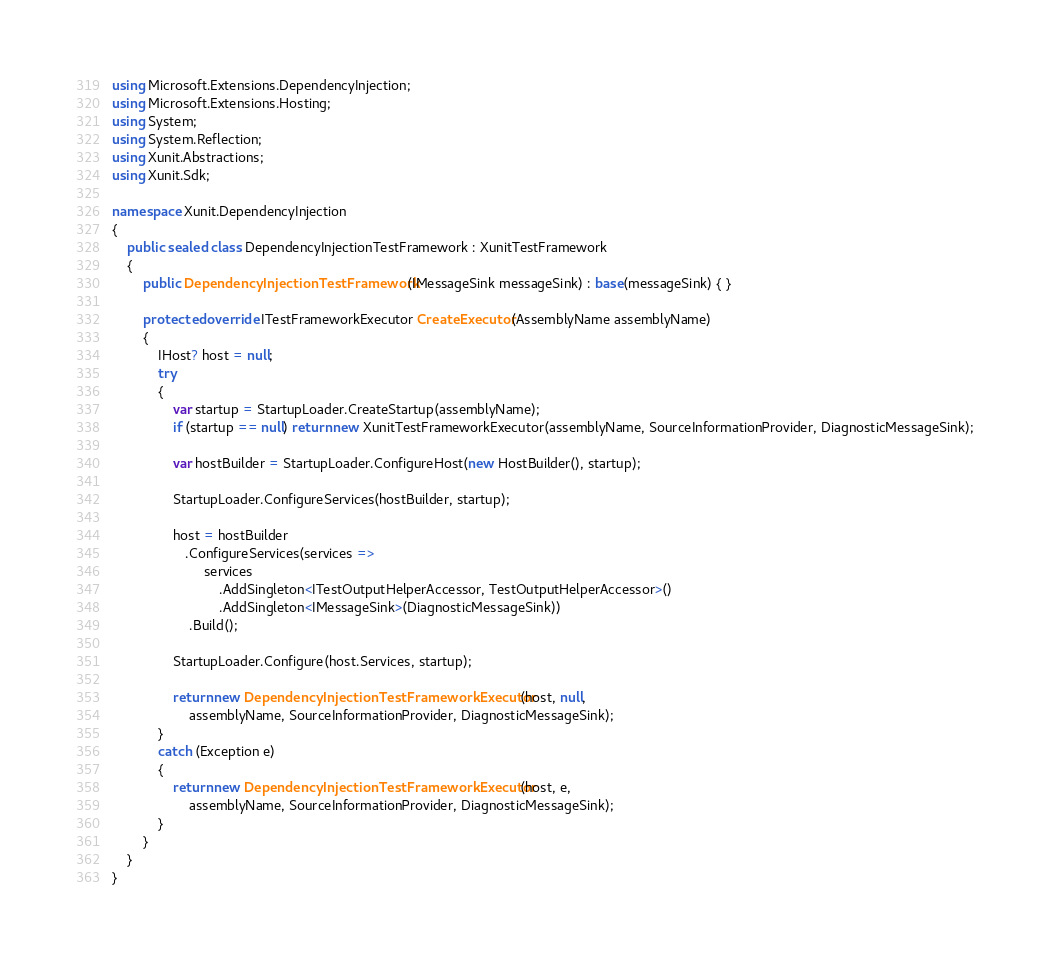<code> <loc_0><loc_0><loc_500><loc_500><_C#_>using Microsoft.Extensions.DependencyInjection;
using Microsoft.Extensions.Hosting;
using System;
using System.Reflection;
using Xunit.Abstractions;
using Xunit.Sdk;

namespace Xunit.DependencyInjection
{
    public sealed class DependencyInjectionTestFramework : XunitTestFramework
    {
        public DependencyInjectionTestFramework(IMessageSink messageSink) : base(messageSink) { }

        protected override ITestFrameworkExecutor CreateExecutor(AssemblyName assemblyName)
        {
            IHost? host = null;
            try
            {
                var startup = StartupLoader.CreateStartup(assemblyName);
                if (startup == null) return new XunitTestFrameworkExecutor(assemblyName, SourceInformationProvider, DiagnosticMessageSink);

                var hostBuilder = StartupLoader.ConfigureHost(new HostBuilder(), startup);

                StartupLoader.ConfigureServices(hostBuilder, startup);

                host = hostBuilder
                   .ConfigureServices(services =>
                        services
                            .AddSingleton<ITestOutputHelperAccessor, TestOutputHelperAccessor>()
                            .AddSingleton<IMessageSink>(DiagnosticMessageSink))
                    .Build();

                StartupLoader.Configure(host.Services, startup);

                return new DependencyInjectionTestFrameworkExecutor(host, null,
                    assemblyName, SourceInformationProvider, DiagnosticMessageSink);
            }
            catch (Exception e)
            {
                return new DependencyInjectionTestFrameworkExecutor(host, e,
                    assemblyName, SourceInformationProvider, DiagnosticMessageSink);
            }
        }
    }
}
</code> 